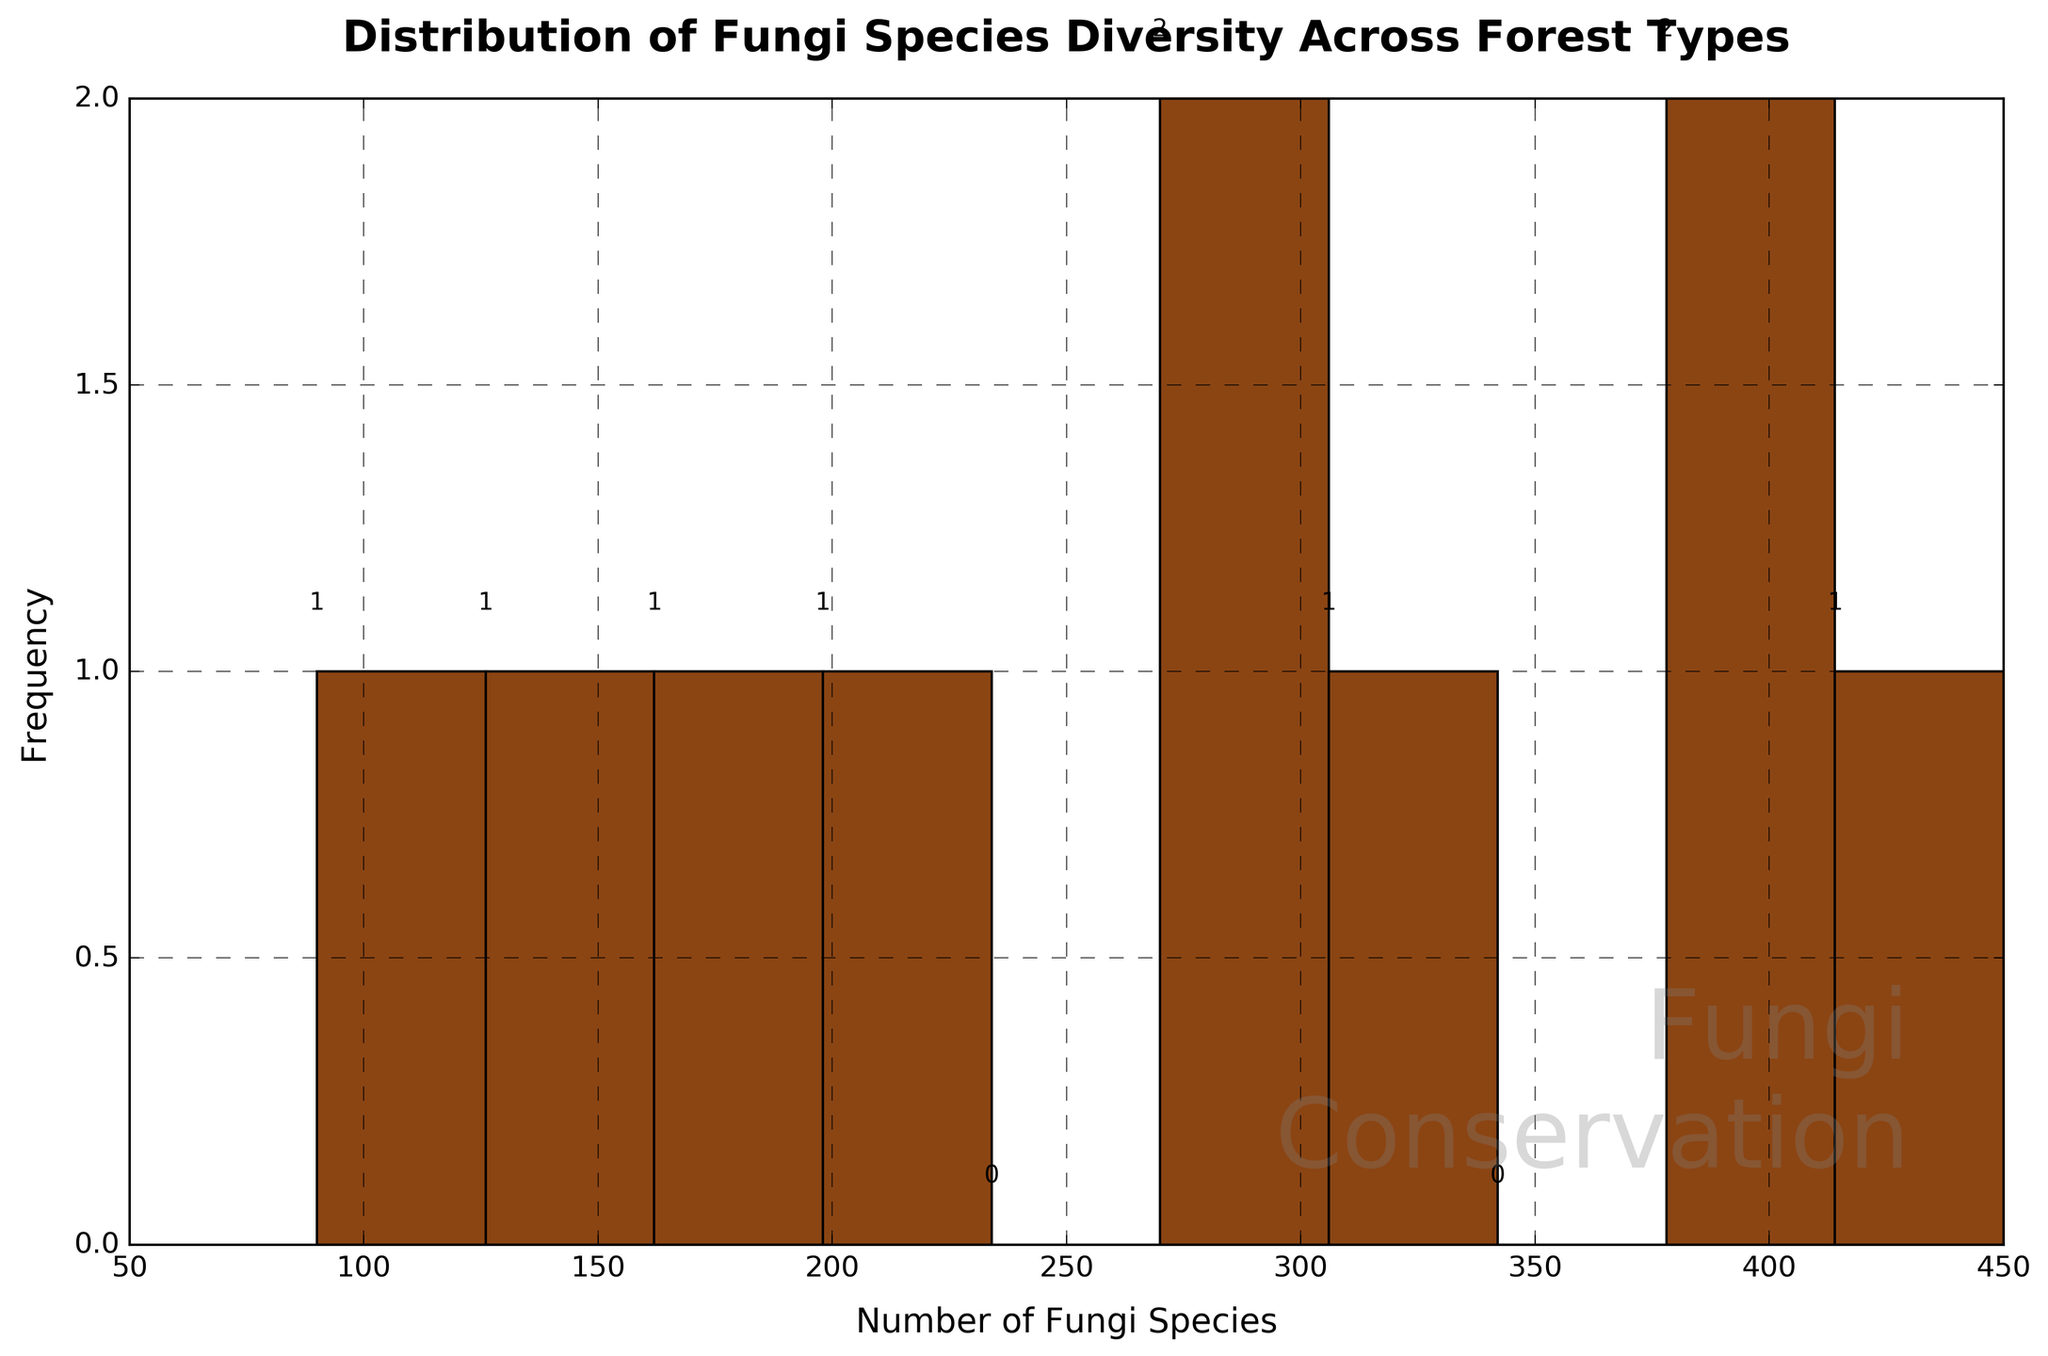How many forest types are represented in the histogram? Count the number of bars on the histogram; each bar represents a forest type.
Answer: 10 What is the title of the histogram? Look at the top of the histogram where the title is prominently displayed in bold text.
Answer: Distribution of Fungi Species Diversity Across Forest Types Which forest type has the highest number of fungi species? Examine the histogram and identify the bar representing the highest frequency count; cross-match that bar with the corresponding forest type.
Answer: Tropical Rainforest What is the range of fungi species diversity shown in the histogram? Look at the minimum and maximum bin edges on the x-axis, which show the range of fungi species diversity.
Answer: 90 to 450 How many forest types have a number of fungi species between 200 and 300? Count the number of bars that fall within the bin edges representing the intervals 200 to 300 on the x-axis.
Answer: 2 Which forest type has the lowest number of fungi species? Identify the bar with the smallest frequency count and cross-match it with the corresponding forest type.
Answer: Mangrove Forest What is the average number of fungi species across all forest types? Sum the number of species in all forest types and divide by the number of forest types, i.e., (450 + 320 + 180 + 280 + 210 + 90 + 380 + 290 +150 + 410) / 10.
Answer: 276 Which intervals or bins have no forest types represented? Look for bins in the histogram with no bars present; these intervals show no data points.
Answer: 450-460 and 90-100 What is the median number of fungi species across all forest types? Arrange the data in ascending order and find the middle value. If there is an even number of data points, average the two middle values, i.e., (90, 150, 180, 210, 280, 290, 320, 380, 410, 450).
Answer: 285 In which bin interval does the most frequent number of fungi species fall? Identify the bin on the x-axis that has the highest bar (frequency).
Answer: 270-300 